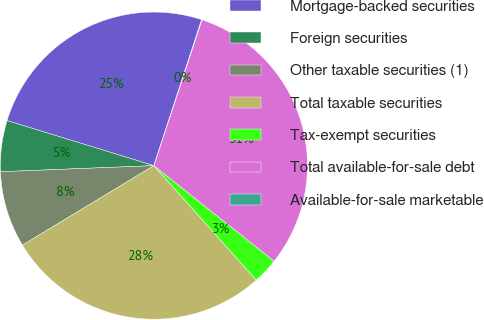Convert chart. <chart><loc_0><loc_0><loc_500><loc_500><pie_chart><fcel>Mortgage-backed securities<fcel>Foreign securities<fcel>Other taxable securities (1)<fcel>Total taxable securities<fcel>Tax-exempt securities<fcel>Total available-for-sale debt<fcel>Available-for-sale marketable<nl><fcel>25.29%<fcel>5.37%<fcel>8.03%<fcel>27.95%<fcel>2.71%<fcel>30.61%<fcel>0.05%<nl></chart> 